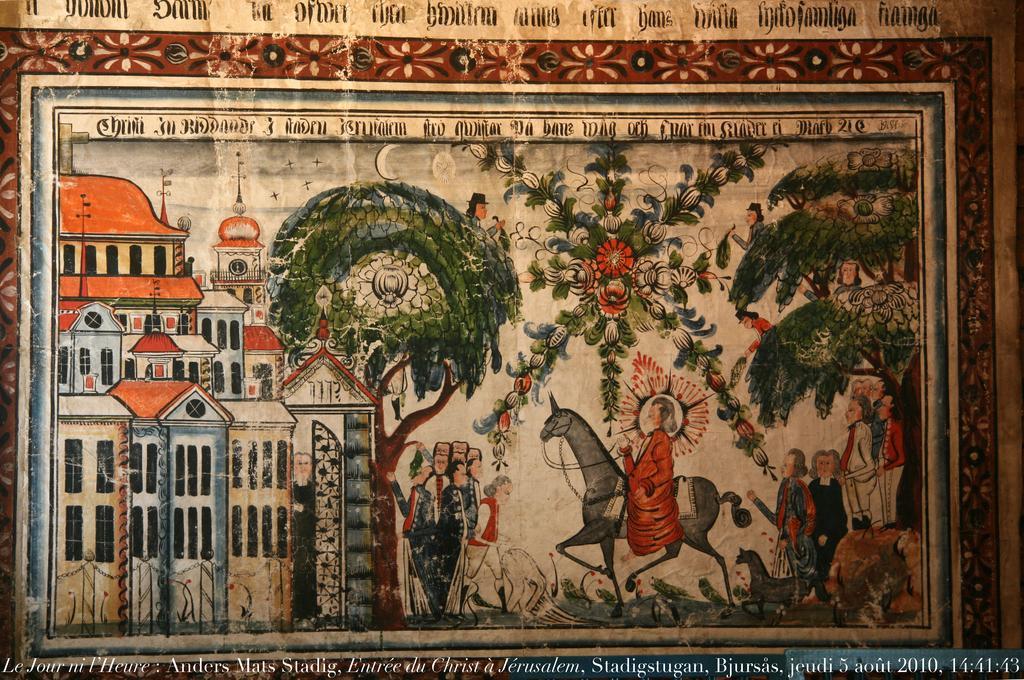Could you give a brief overview of what you see in this image? In this image we can see the painting. In the painting we can see the house on the left side. Here we can see a person sitting on a horse. Here we can see few persons. Here we can see the trees. 